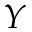<formula> <loc_0><loc_0><loc_500><loc_500>Y</formula> 